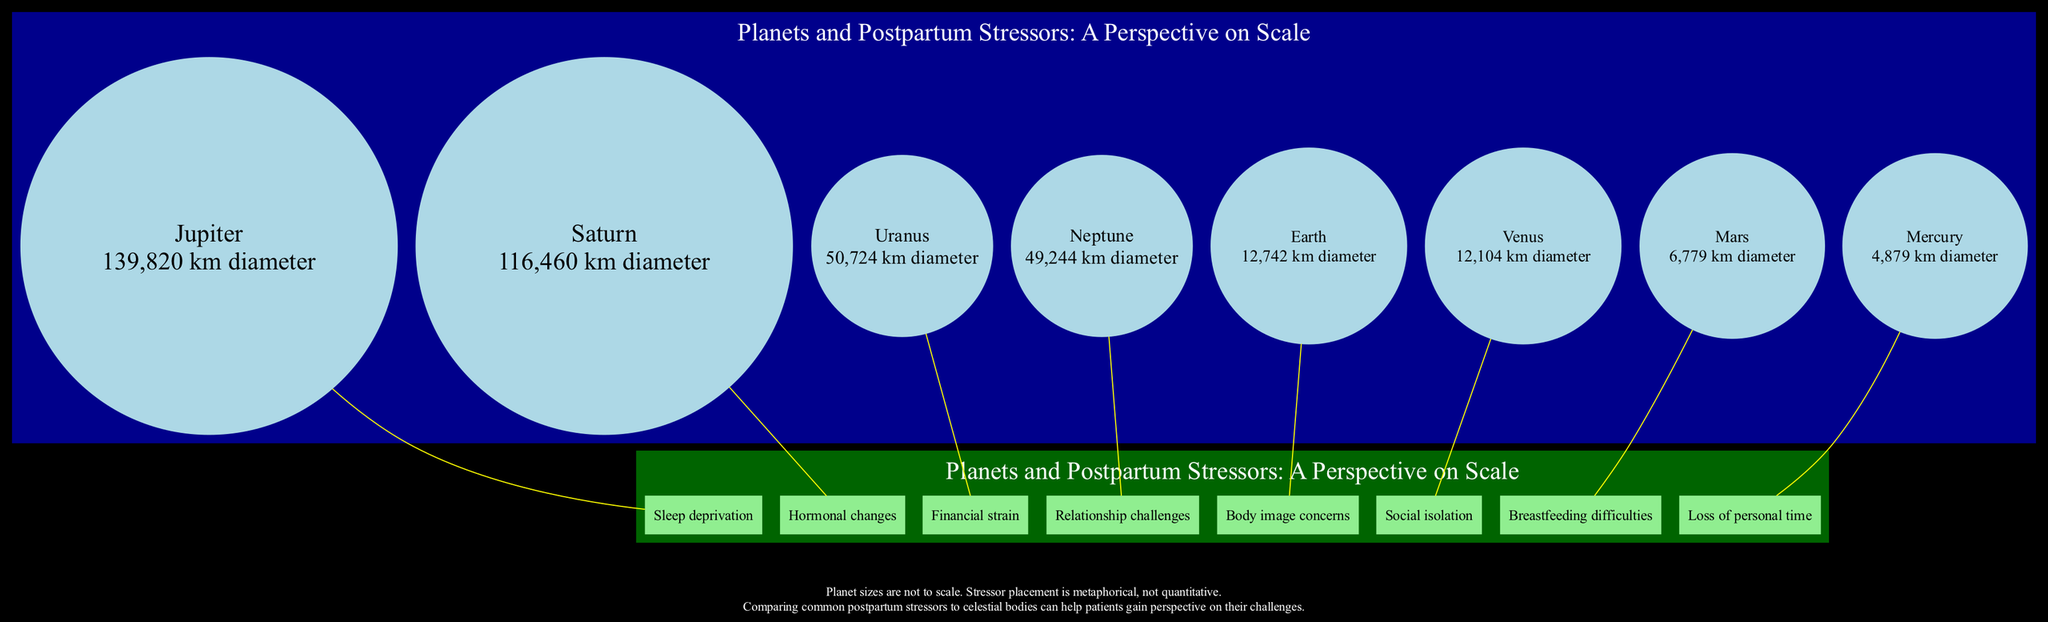What is the diameter of Jupiter? The diameter of Jupiter is provided next to its name in the diagram. It states "139,820 km diameter" directly.
Answer: 139,820 km diameter Which postpartum stressor is associated with Venus? By examining the node connected to Venus, we see it is linked to the label "Social isolation," which represents the related postpartum stressor.
Answer: Social isolation How many celestial bodies are depicted in the diagram? To find the answer, we count the number of planets in the provided data, which totals eight celestial bodies.
Answer: 8 Which planet represents "Financial strain"? The diagram indicates the connection between Uranus and the stressor labeled "Financial strain." Therefore, Uranus represents this stressor.
Answer: Uranus What is the relationship between Earth and the postpartum stressor it is linked to? Earth is directly connected to "Body image concerns" in the diagram. This shows that Earth represents this particular postpartum stressor.
Answer: Body image concerns Between Jupiter and Saturn, which is larger? The sizes of both Jupiter and Saturn are indicated in the diagram. Jupiter has a diameter of "139,820 km," whereas Saturn's diameter is "116,460 km." Thus, Jupiter is larger.
Answer: Jupiter What color is used to represent the related stressors in the diagram? The nodes for the postpartum stressors are shown in light green as indicated by the graph's node attribute, which specifies the stressors.
Answer: Light green Which celestial body is the smallest in the diagram? Among the listed celestial bodies, Mercury has the smallest diameter of "4,879 km," making it the smallest in size shown.
Answer: Mercury What metaphorical purpose does the note at the bottom of the diagram serve? The note explains that the sizes of planets are not to scale and that stressor placement is metaphorical. This suggests that the comparisons aid in understanding postpartum challenges.
Answer: Perspective on challenges 